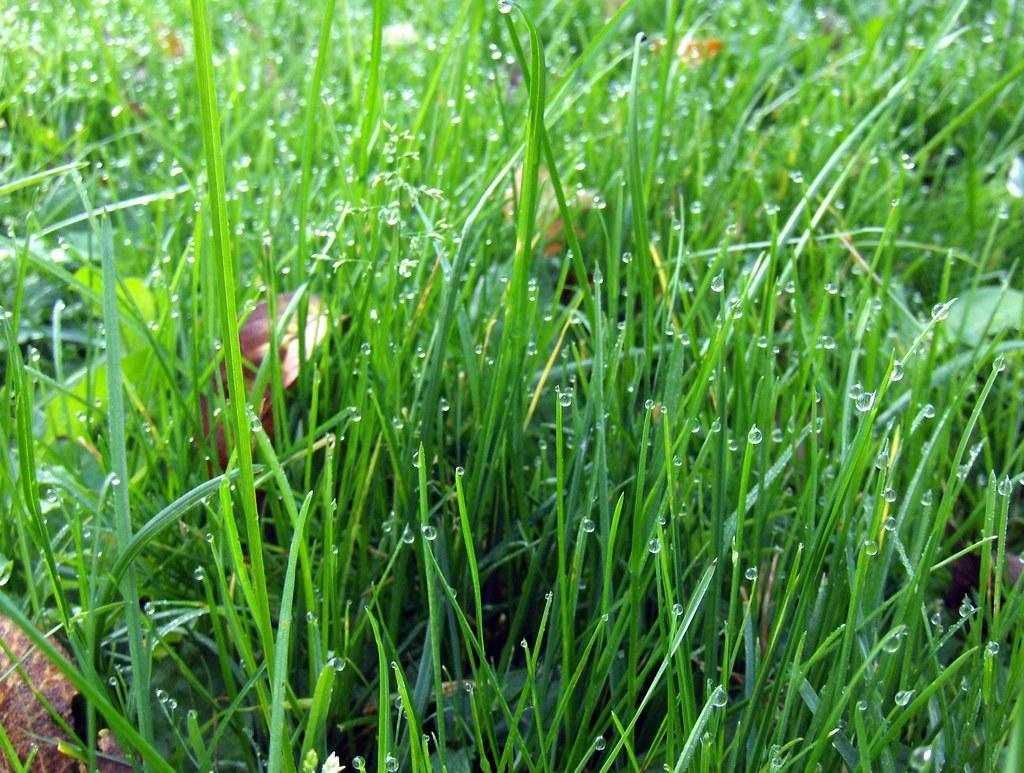In one or two sentences, can you explain what this image depicts? In this image i can see grasses on the ground and there are many water drops. 